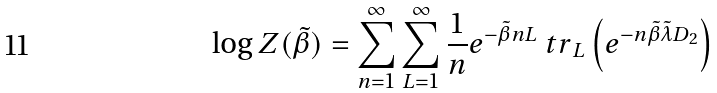<formula> <loc_0><loc_0><loc_500><loc_500>\log Z ( \tilde { \beta } ) = \sum _ { n = 1 } ^ { \infty } \sum _ { L = 1 } ^ { \infty } \frac { 1 } { n } e ^ { - \tilde { \beta } n L } { \ t r } _ { L } \left ( e ^ { - n \tilde { \beta } \tilde { \lambda } D _ { 2 } } \right )</formula> 